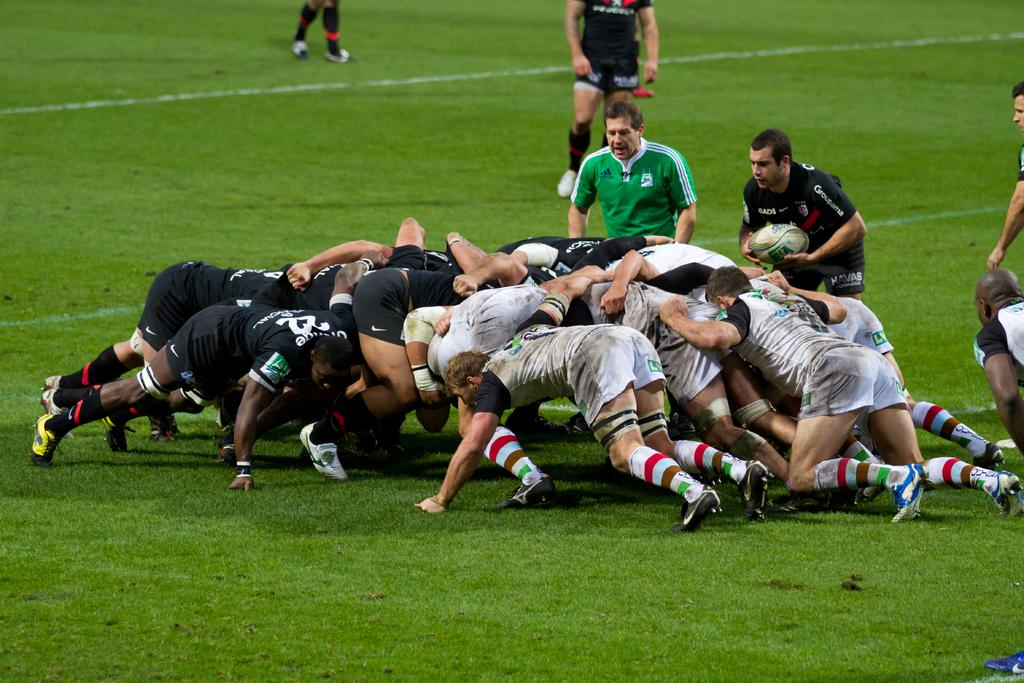How many people are in the image? There are persons in the image, but the exact number is not specified. What are the persons in the image wearing? The persons in the image are wearing clothes. What sport are the persons playing in the image? The persons are playing rugby in the image. Can you describe the person on the right side of the image? There is a person on the right side of the image holding a ball with his hands. What is the surface on which the persons are playing? There is grass on the ground in the image. What type of animals can be seen in the zoo in the image? There is no zoo present in the image, and therefore no animals can be seen. What type of rhythm is the cattle following in the image? There is no cattle present in the image, and therefore no rhythm can be observed. 